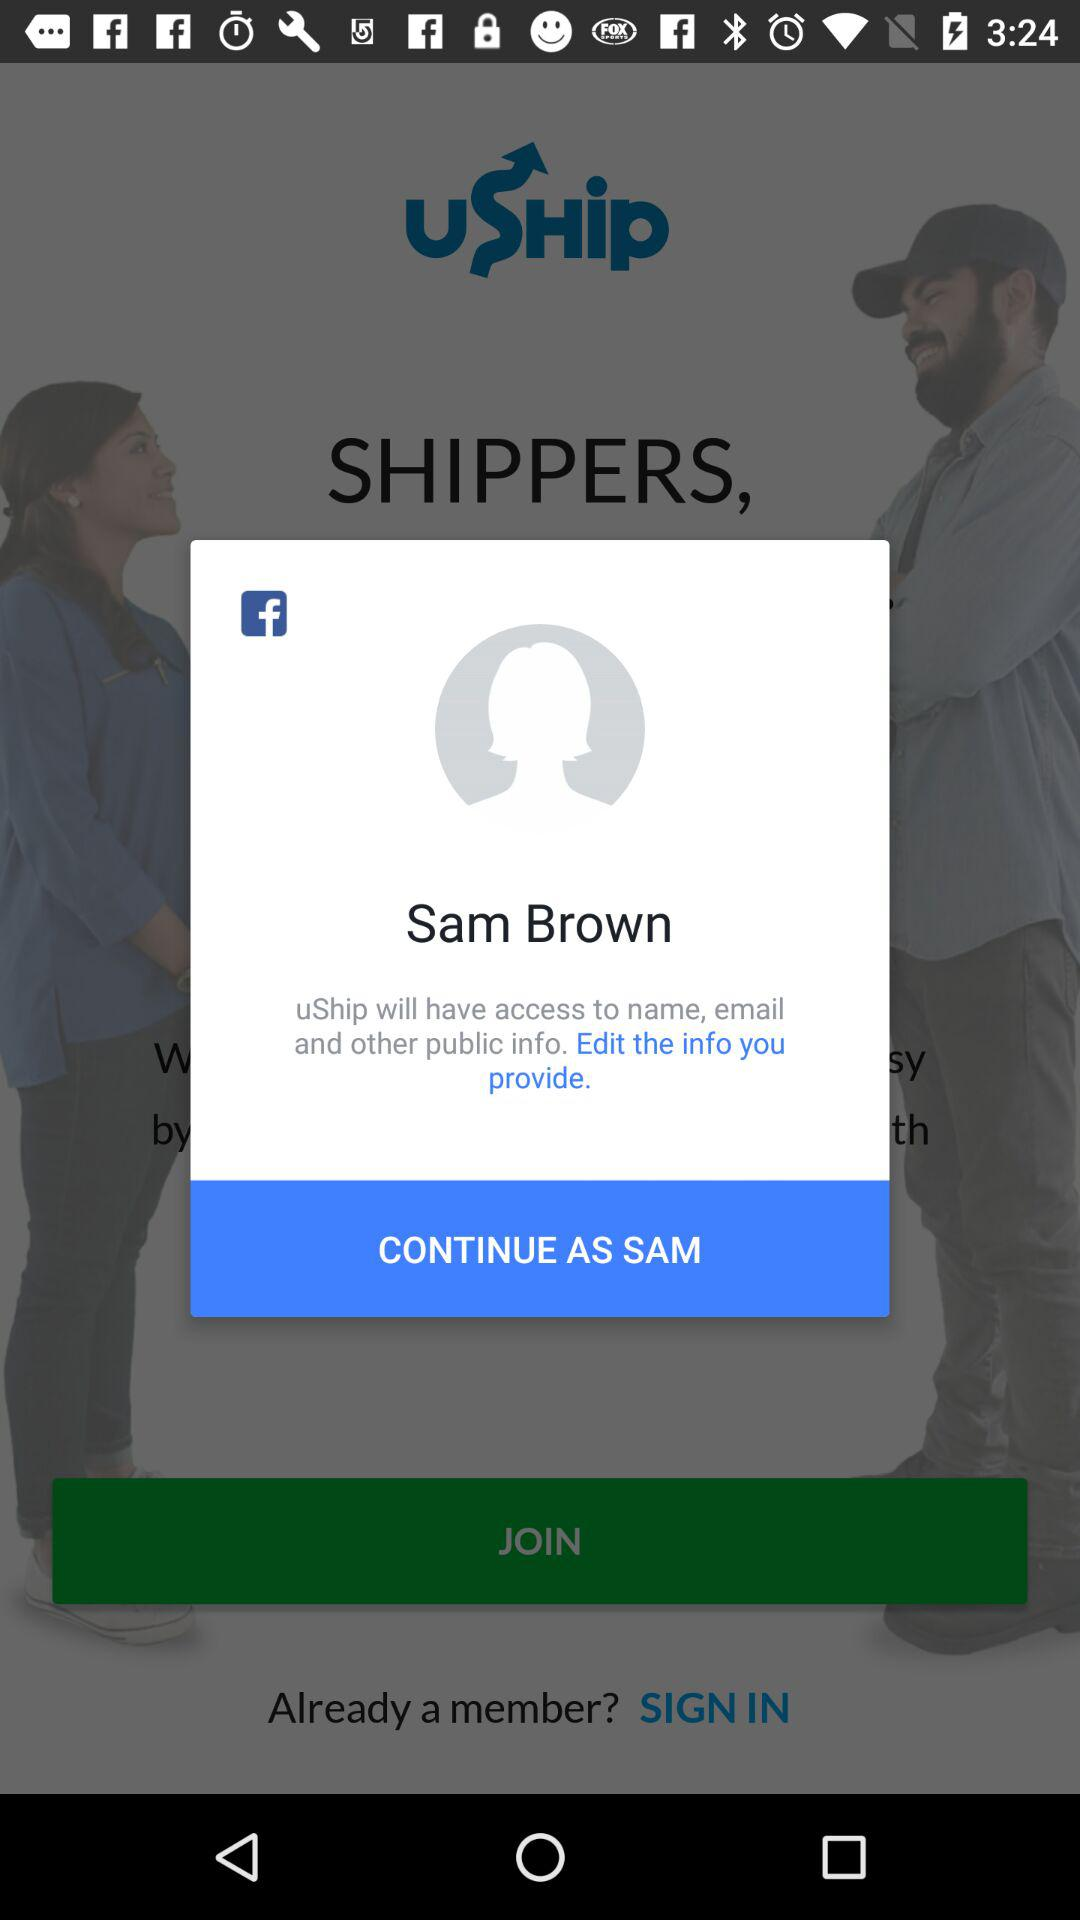What is the user name? The user name is "Sam Brown". 